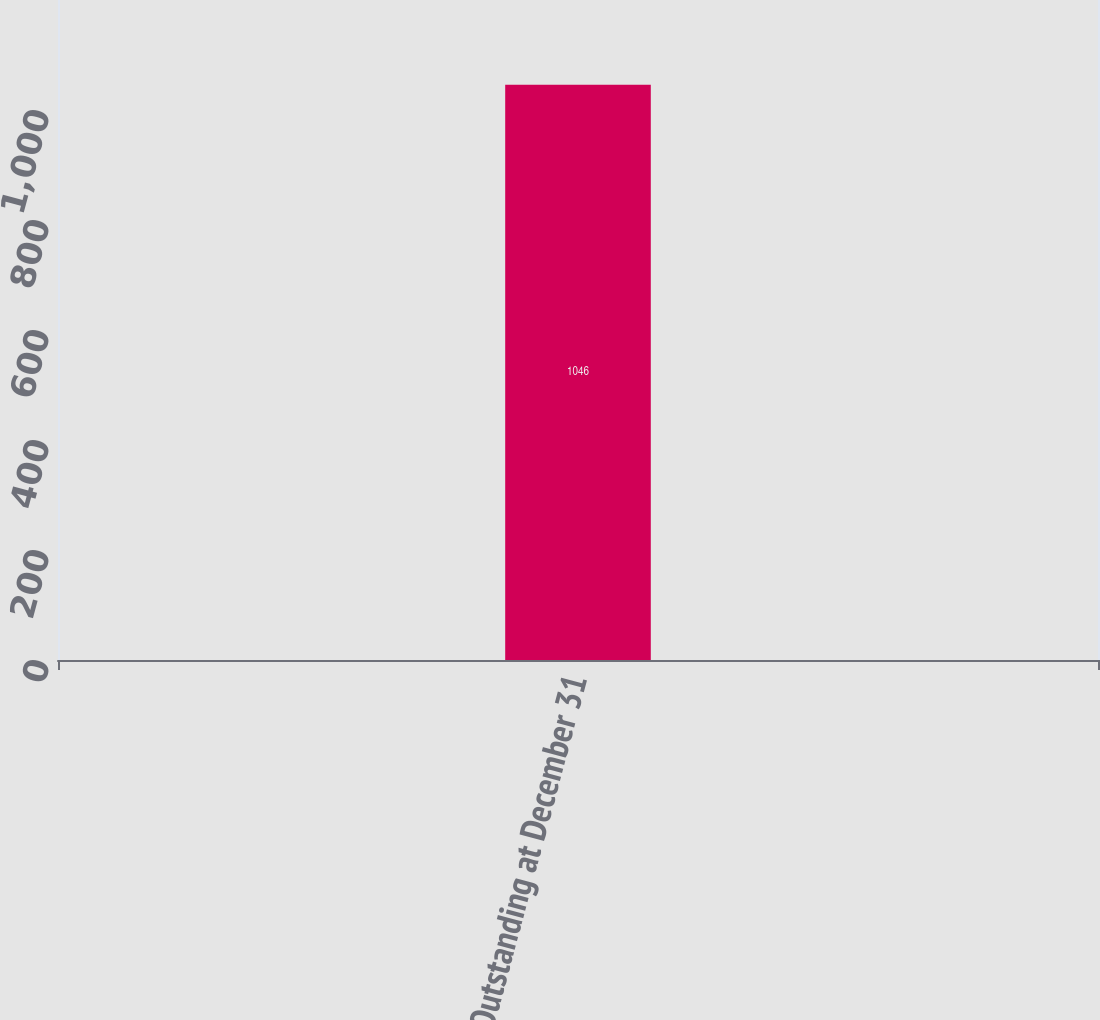Convert chart. <chart><loc_0><loc_0><loc_500><loc_500><bar_chart><fcel>Outstanding at December 31<nl><fcel>1046<nl></chart> 